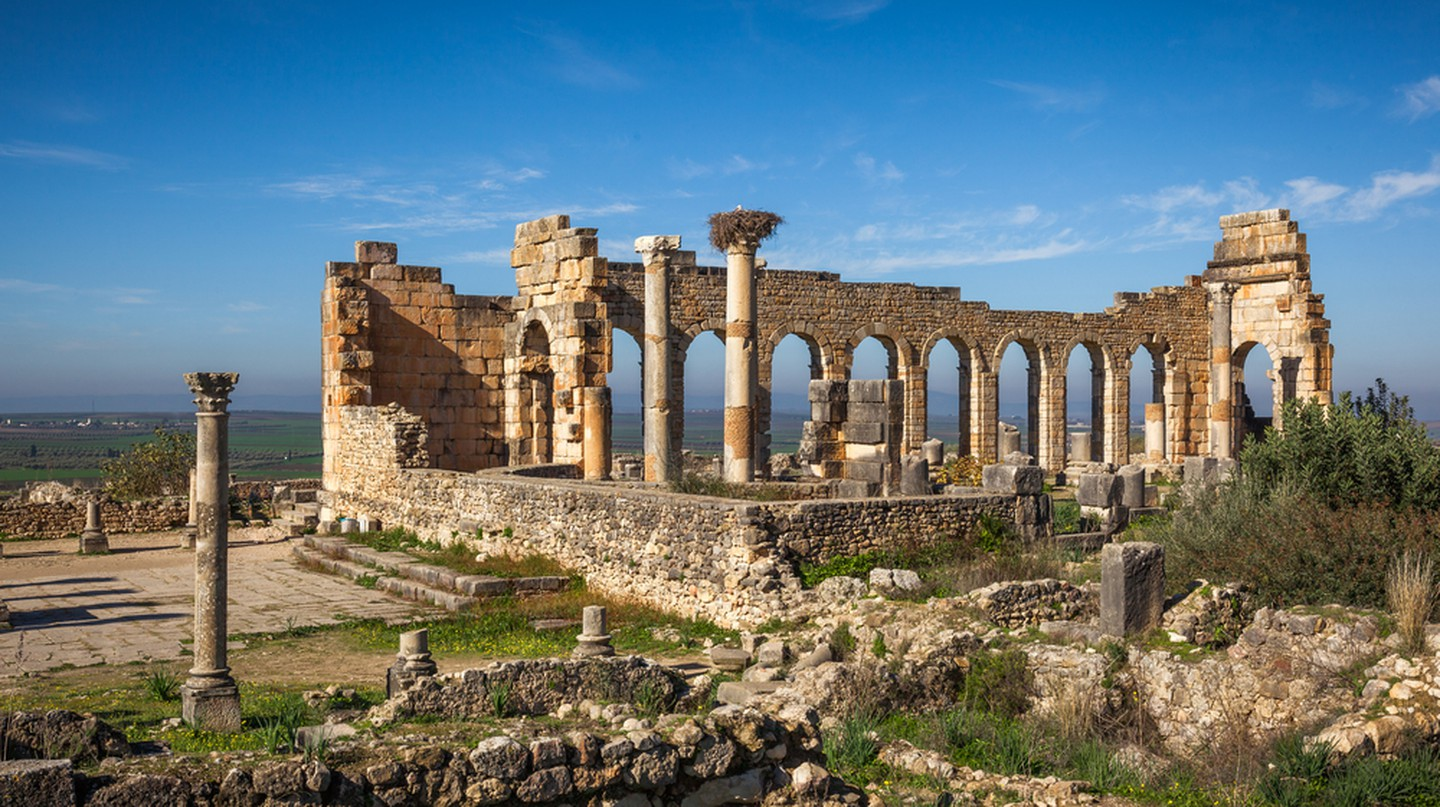Can you explain the architectural styles visible in this image? Certainly! The ruins of Volubilis exhibit a blend of Roman and local architectural styles, showcasing the cultural synthesis typical of Roman provincial cities. The iconic columns and arches show classical Roman design, known for its emphasis on symmetry, geometry, and the use of locally sourced limestone. Additionally, the ruins include elements like the basilica and the triumphal arch, which were central to Roman towns. Some local influences can be seen in the adaptation of the buildings to the local climate, including thicker walls and the use of local decorative motifs. 